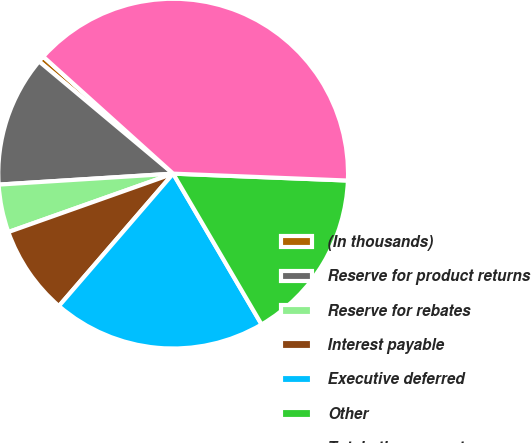Convert chart to OTSL. <chart><loc_0><loc_0><loc_500><loc_500><pie_chart><fcel>(In thousands)<fcel>Reserve for product returns<fcel>Reserve for rebates<fcel>Interest payable<fcel>Executive deferred<fcel>Other<fcel>Total other current<nl><fcel>0.58%<fcel>12.09%<fcel>4.42%<fcel>8.25%<fcel>19.77%<fcel>15.93%<fcel>38.96%<nl></chart> 